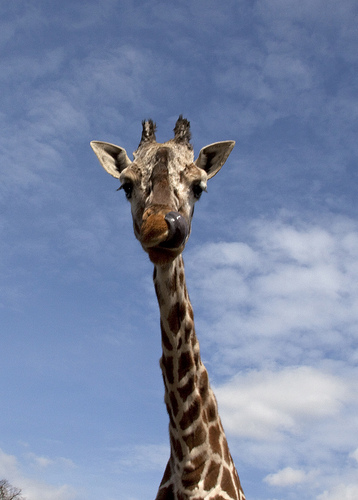<image>
Can you confirm if the giraffe is in the sky? No. The giraffe is not contained within the sky. These objects have a different spatial relationship. 